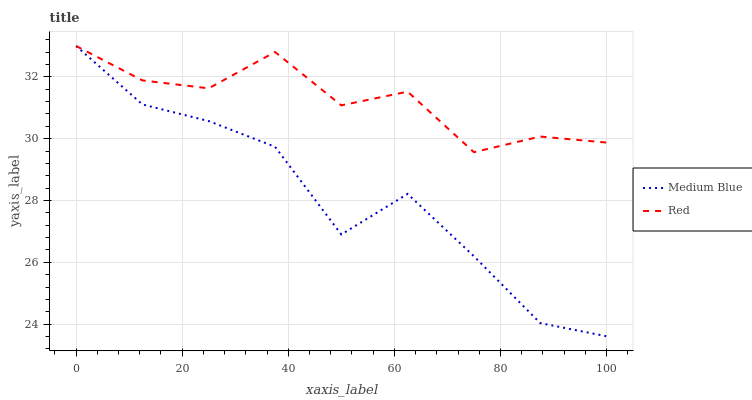Does Medium Blue have the minimum area under the curve?
Answer yes or no. Yes. Does Red have the maximum area under the curve?
Answer yes or no. Yes. Does Red have the minimum area under the curve?
Answer yes or no. No. Is Red the smoothest?
Answer yes or no. Yes. Is Medium Blue the roughest?
Answer yes or no. Yes. Is Red the roughest?
Answer yes or no. No. Does Red have the lowest value?
Answer yes or no. No. 